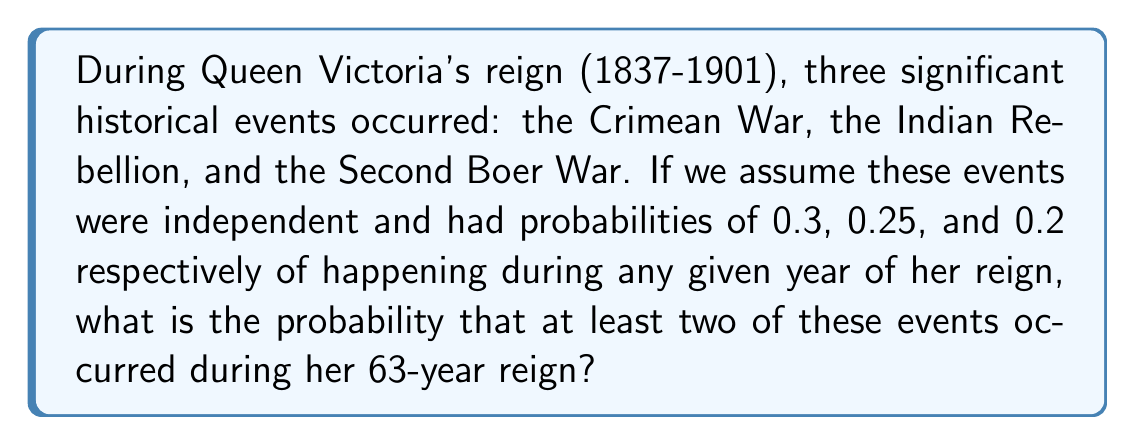Can you answer this question? Let's approach this step-by-step using probability theory:

1) First, let's calculate the probability of each event occurring during the 63-year reign:

   For each event, the probability of it not occurring in a given year is:
   Crimean War: $1 - 0.3 = 0.7$
   Indian Rebellion: $1 - 0.25 = 0.75$
   Second Boer War: $1 - 0.2 = 0.8$

   The probability of each event not occurring for 63 years is:
   Crimean War: $0.7^{63}$
   Indian Rebellion: $0.75^{63}$
   Second Boer War: $0.8^{63}$

   Therefore, the probability of each event occurring at least once is:
   Crimean War: $P(C) = 1 - 0.7^{63}$
   Indian Rebellion: $P(I) = 1 - 0.75^{63}$
   Second Boer War: $P(B) = 1 - 0.8^{63}$

2) Now, we need to find the probability of at least two events occurring. It's easier to calculate the complement of this: the probability of 0 or 1 event occurring.

3) Probability of 0 events occurring:
   $P(\text{none}) = (0.7^{63})(0.75^{63})(0.8^{63})$

4) Probability of exactly 1 event occurring:
   $P(\text{only C}) = (1-0.7^{63})(0.75^{63})(0.8^{63})$
   $P(\text{only I}) = (0.7^{63})(1-0.75^{63})(0.8^{63})$
   $P(\text{only B}) = (0.7^{63})(0.75^{63})(1-0.8^{63})$

5) Probability of 0 or 1 event:
   $P(0 \text{ or } 1) = P(\text{none}) + P(\text{only C}) + P(\text{only I}) + P(\text{only B})$

6) Therefore, the probability of at least 2 events is:
   $P(\text{at least 2}) = 1 - P(0 \text{ or } 1)$

Calculating this:
$P(\text{at least 2}) = 1 - [(0.7^{63})(0.75^{63})(0.8^{63}) + (1-0.7^{63})(0.75^{63})(0.8^{63}) + (0.7^{63})(1-0.75^{63})(0.8^{63}) + (0.7^{63})(0.75^{63})(1-0.8^{63})]$
Answer: $P(\text{at least 2}) \approx 0.9999999999999999$ or essentially 1

This means it was virtually certain that at least two of these events would occur during Queen Victoria's reign, which aligns with historical fact as all three events did indeed take place during her reign. 